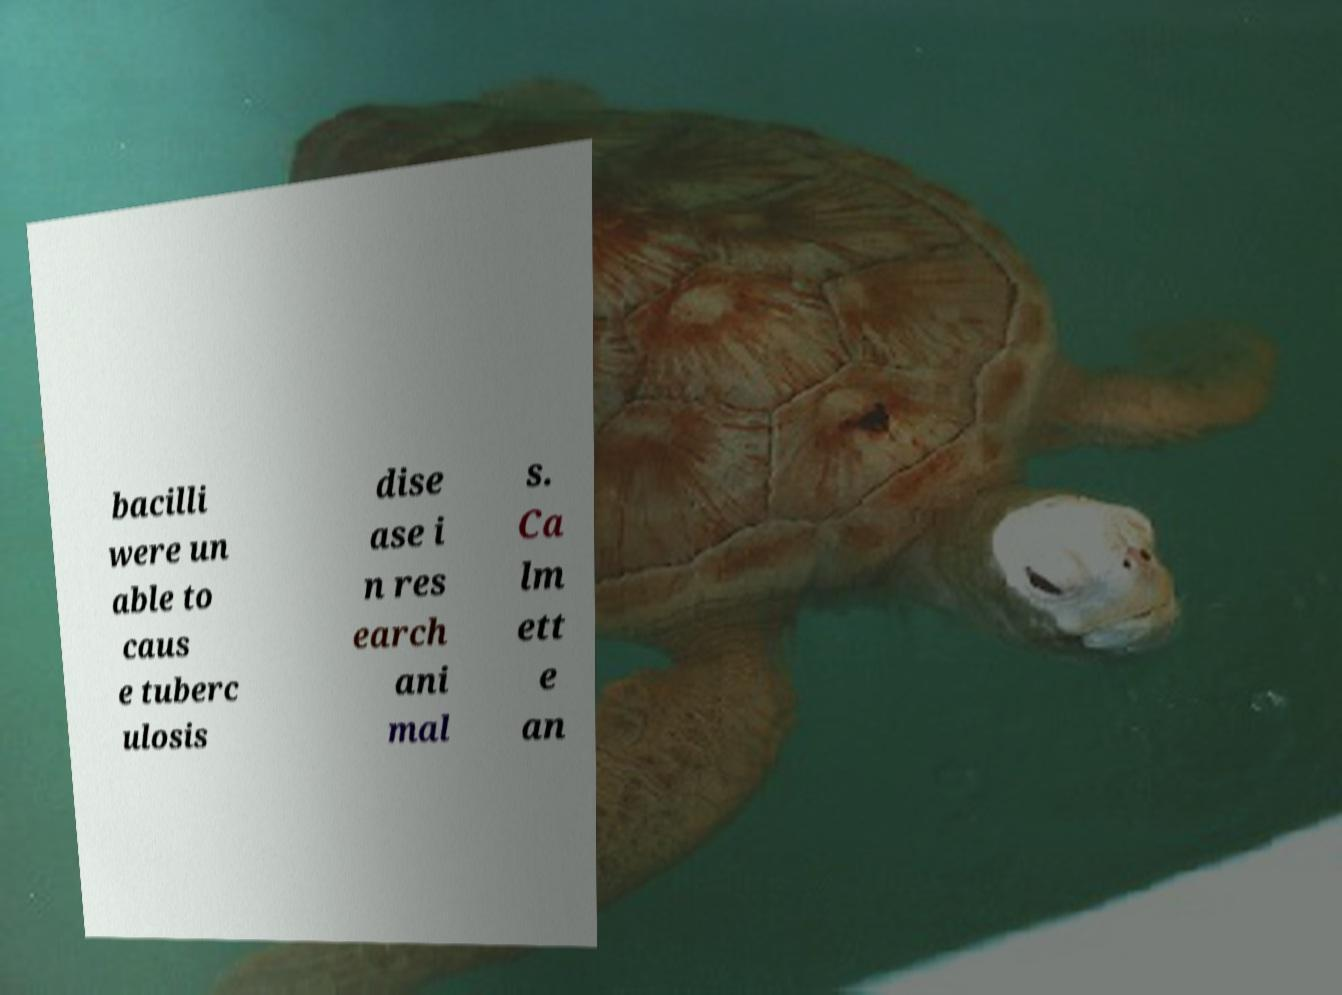There's text embedded in this image that I need extracted. Can you transcribe it verbatim? bacilli were un able to caus e tuberc ulosis dise ase i n res earch ani mal s. Ca lm ett e an 